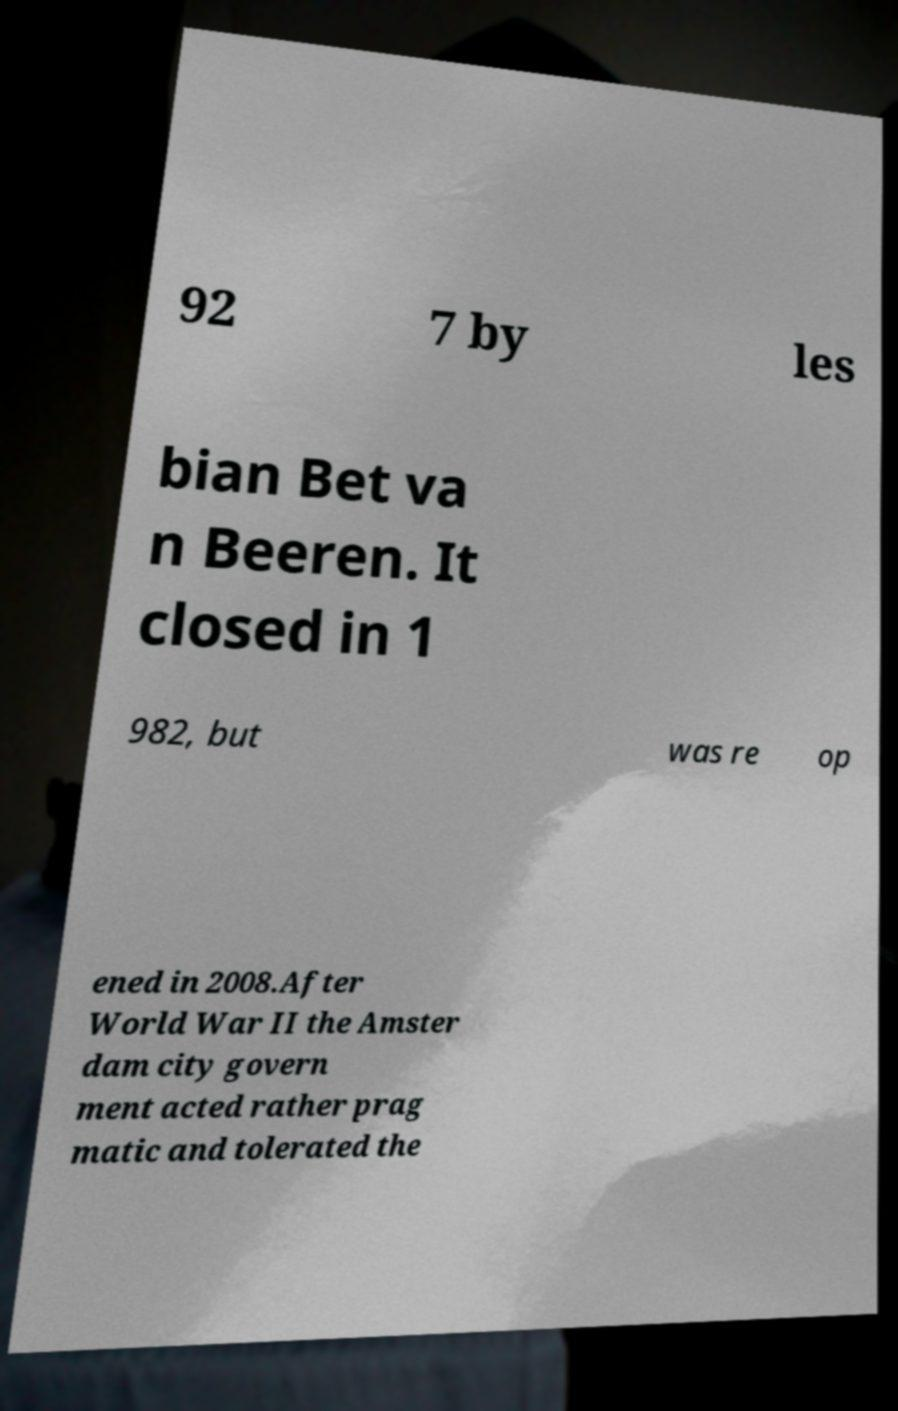Can you read and provide the text displayed in the image?This photo seems to have some interesting text. Can you extract and type it out for me? 92 7 by les bian Bet va n Beeren. It closed in 1 982, but was re op ened in 2008.After World War II the Amster dam city govern ment acted rather prag matic and tolerated the 